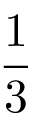<formula> <loc_0><loc_0><loc_500><loc_500>\frac { 1 } { 3 }</formula> 